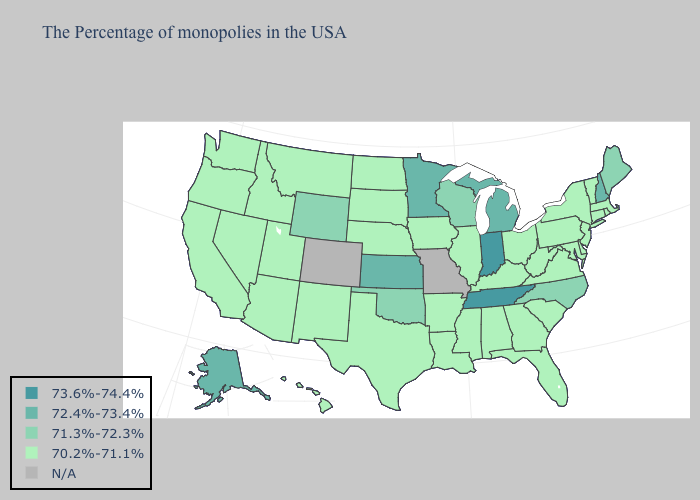How many symbols are there in the legend?
Quick response, please. 5. Name the states that have a value in the range 73.6%-74.4%?
Give a very brief answer. Indiana, Tennessee. Name the states that have a value in the range 73.6%-74.4%?
Write a very short answer. Indiana, Tennessee. What is the value of Wisconsin?
Quick response, please. 71.3%-72.3%. Does Massachusetts have the lowest value in the USA?
Answer briefly. Yes. Name the states that have a value in the range 73.6%-74.4%?
Write a very short answer. Indiana, Tennessee. What is the value of Louisiana?
Short answer required. 70.2%-71.1%. What is the highest value in the MidWest ?
Give a very brief answer. 73.6%-74.4%. What is the highest value in states that border Utah?
Write a very short answer. 71.3%-72.3%. Does Louisiana have the highest value in the South?
Short answer required. No. What is the value of Texas?
Write a very short answer. 70.2%-71.1%. Does the map have missing data?
Give a very brief answer. Yes. Name the states that have a value in the range 72.4%-73.4%?
Quick response, please. New Hampshire, Michigan, Minnesota, Kansas, Alaska. What is the value of Oklahoma?
Write a very short answer. 71.3%-72.3%. 